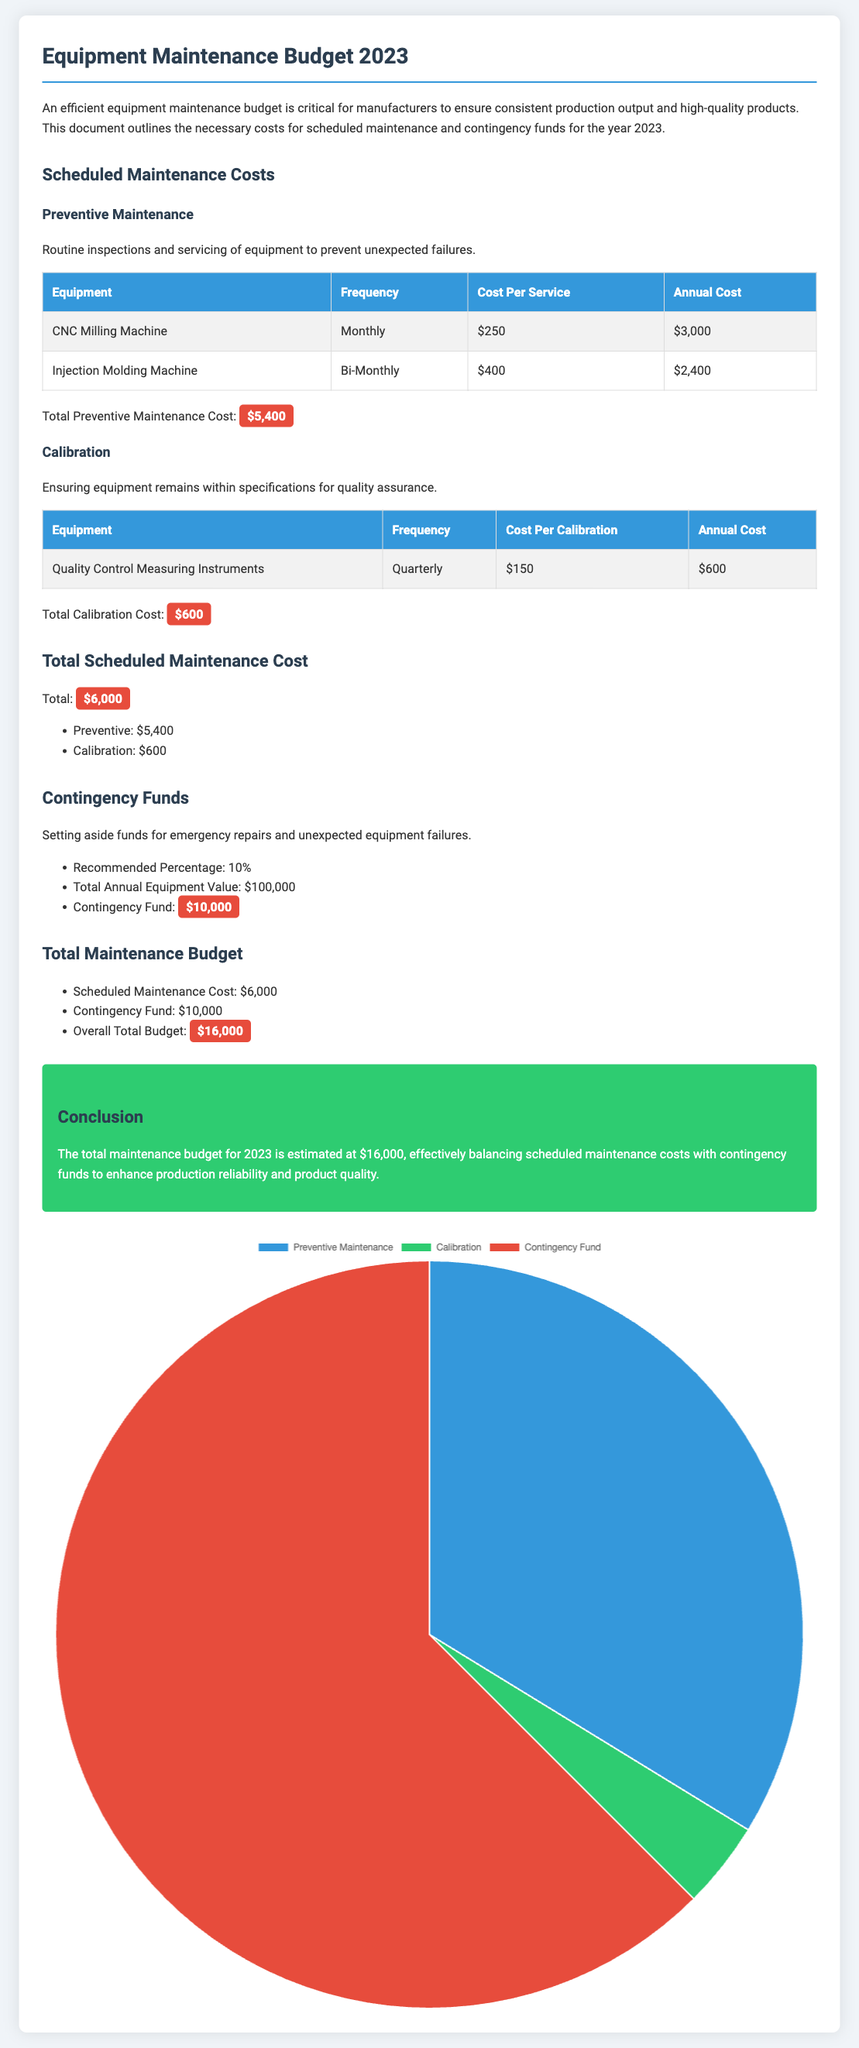What is the total scheduled maintenance cost? The total scheduled maintenance cost is the sum of preventive maintenance and calibration costs, which is $5,400 + $600.
Answer: $6,000 What is the contingency fund amount? The contingency fund is calculated as 10% of the total annual equipment value of $100,000, which equals $10,000.
Answer: $10,000 How often is the CNC Milling Machine serviced? The CNC Milling Machine is serviced monthly for preventive maintenance.
Answer: Monthly What is the cost per calibration for quality control measuring instruments? The cost per calibration for quality control measuring instruments is specified as $150.
Answer: $150 What percentage of the total annual equipment value is allocated for the contingency fund? The document indicates that 10% of the total annual equipment value is set aside for the contingency fund.
Answer: 10% What is the total maintenance budget for 2023? The total maintenance budget is the sum of the scheduled maintenance cost and the contingency fund, which is $6,000 + $10,000.
Answer: $16,000 What is the annual cost for the Injection Molding Machine's preventive maintenance? The annual cost for the Injection Molding Machine's preventive maintenance is given as $2,400.
Answer: $2,400 What type of document is presented here? The document is an equipment maintenance budget for the year 2023.
Answer: Equipment maintenance budget 